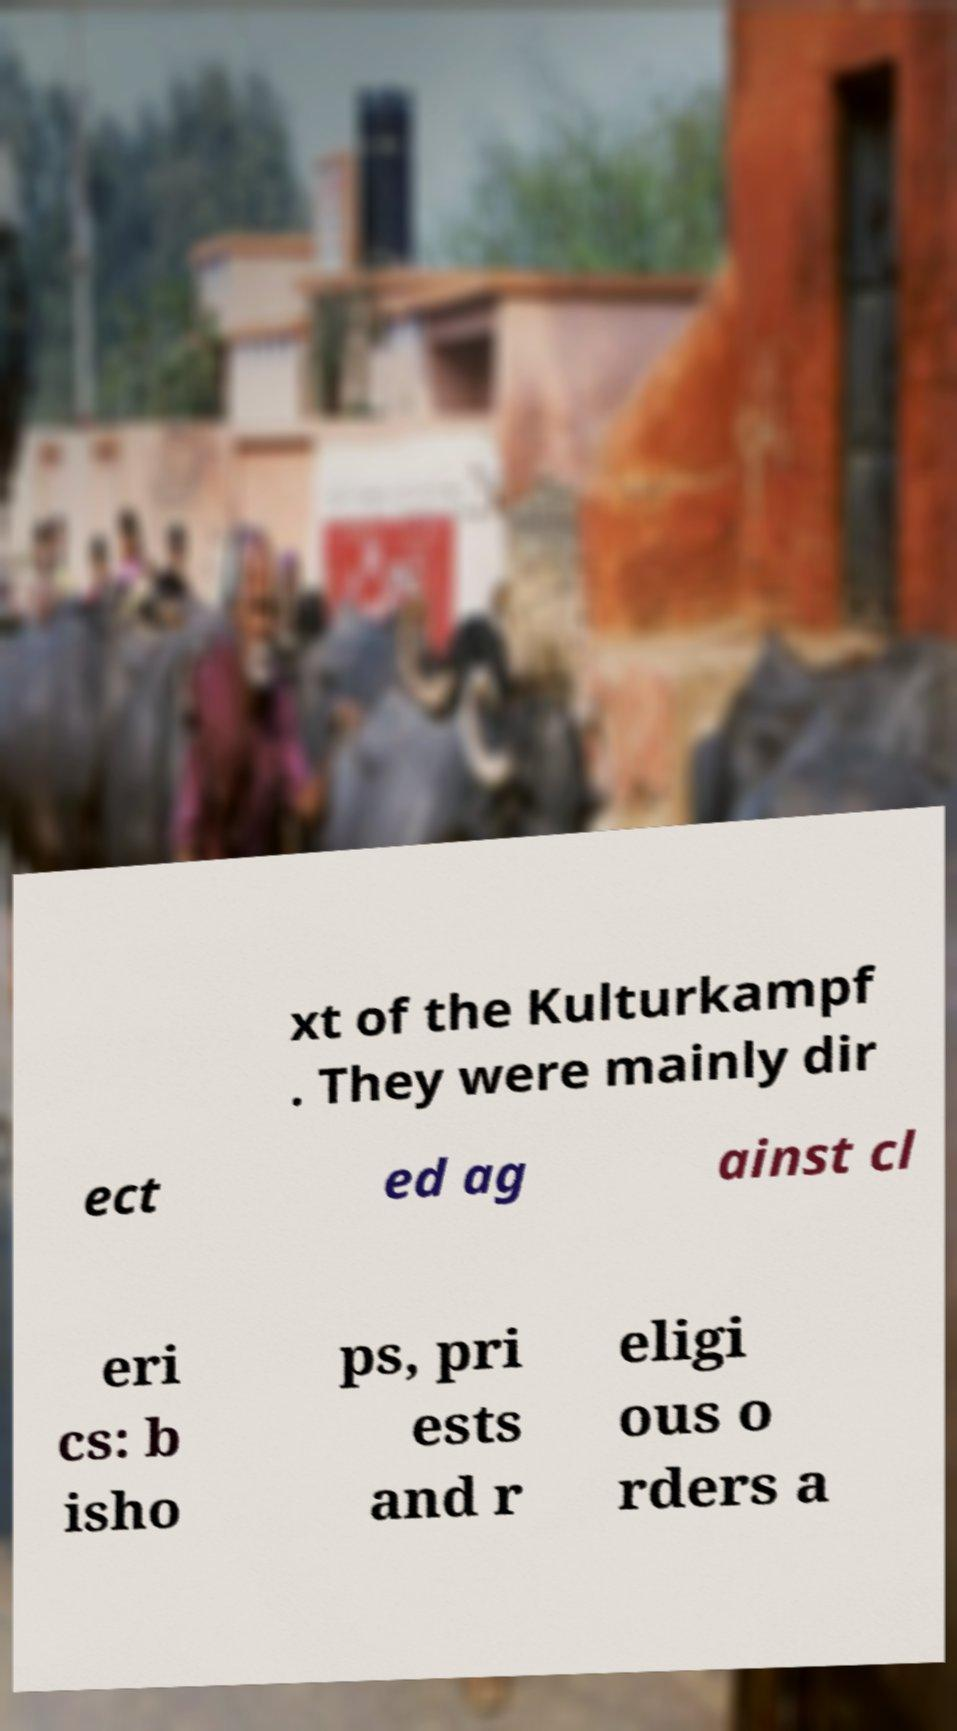What messages or text are displayed in this image? I need them in a readable, typed format. xt of the Kulturkampf . They were mainly dir ect ed ag ainst cl eri cs: b isho ps, pri ests and r eligi ous o rders a 